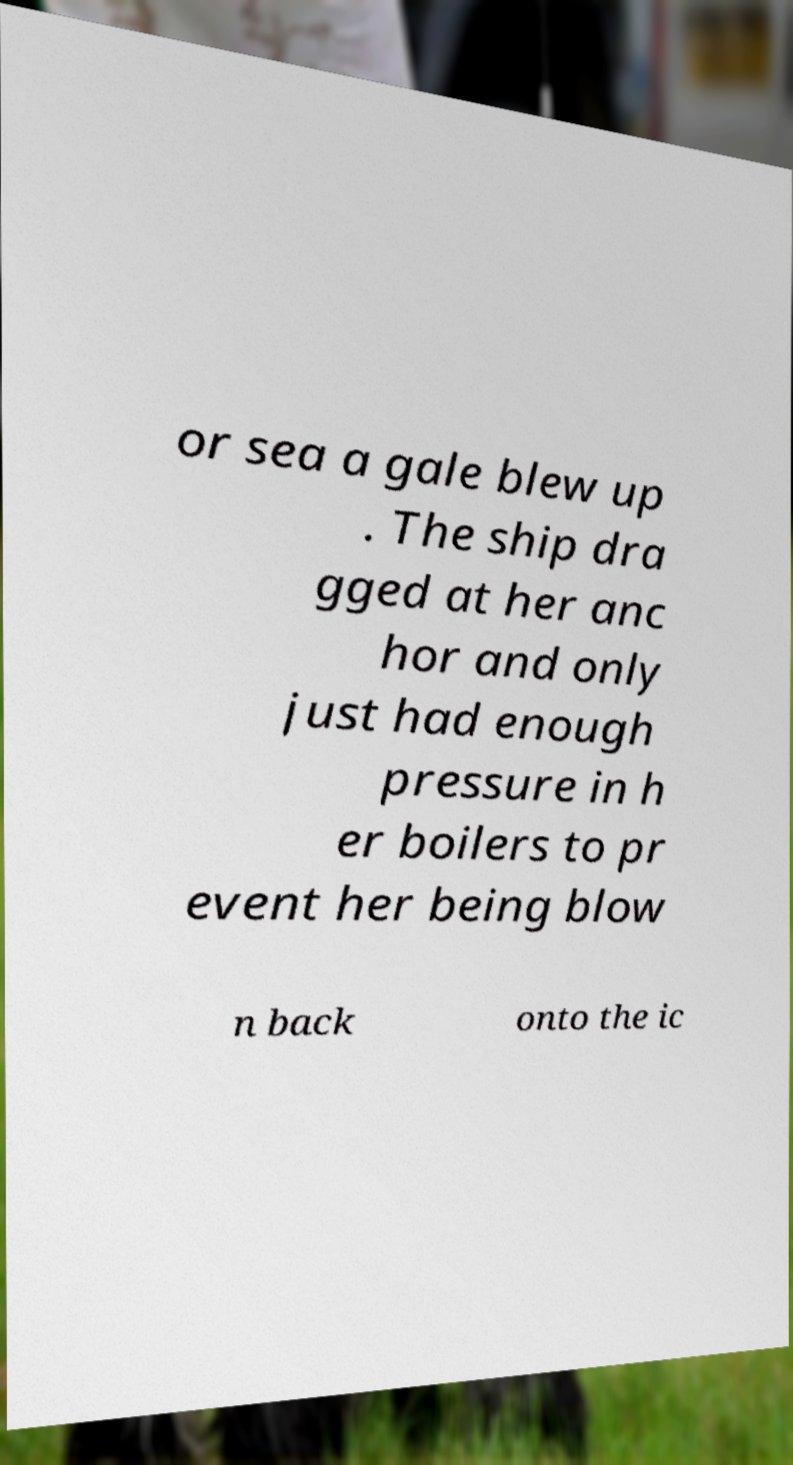Can you accurately transcribe the text from the provided image for me? or sea a gale blew up . The ship dra gged at her anc hor and only just had enough pressure in h er boilers to pr event her being blow n back onto the ic 